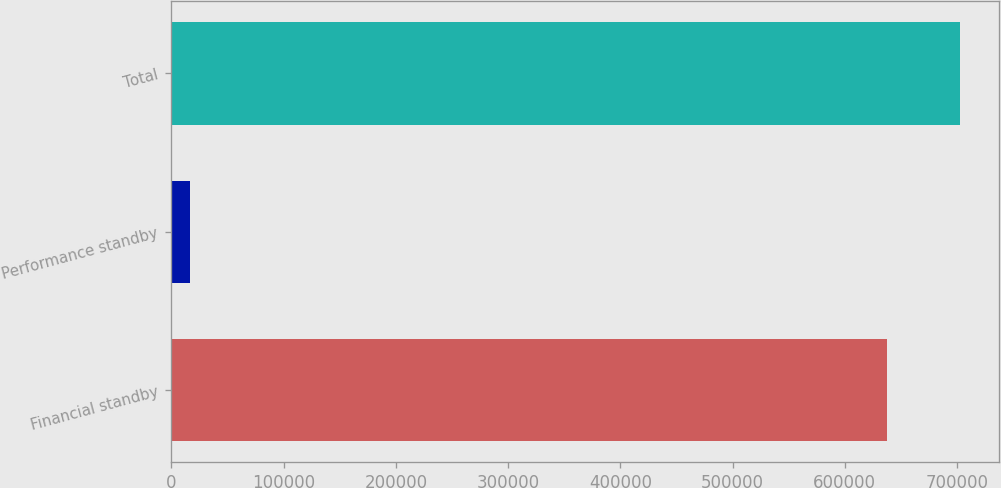<chart> <loc_0><loc_0><loc_500><loc_500><bar_chart><fcel>Financial standby<fcel>Performance standby<fcel>Total<nl><fcel>637321<fcel>16970<fcel>702368<nl></chart> 